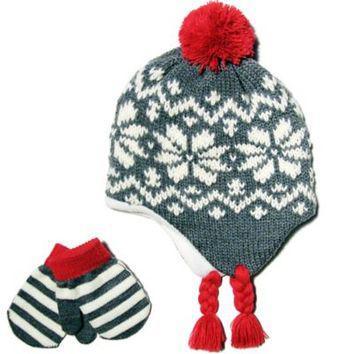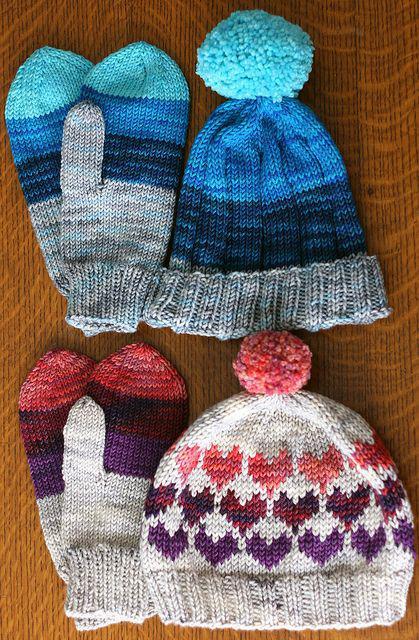The first image is the image on the left, the second image is the image on the right. Evaluate the accuracy of this statement regarding the images: "One hat has an animal face on it.". Is it true? Answer yes or no. No. 